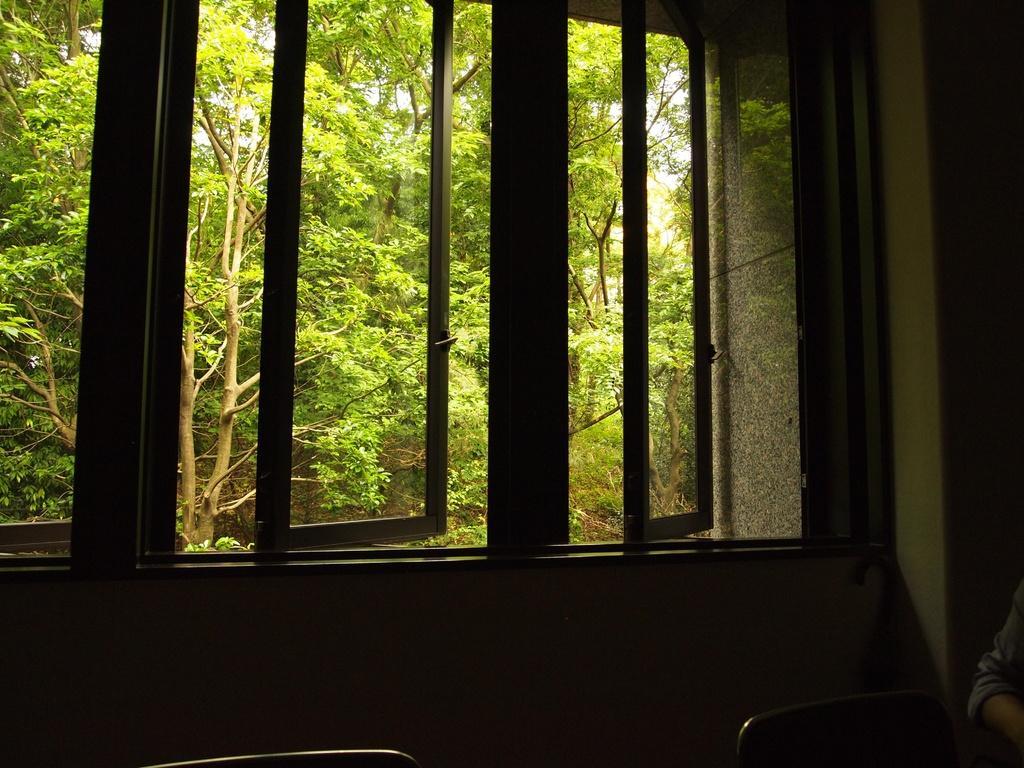Describe this image in one or two sentences. In this image we can see inside view of a building. On the right side of the image we can see a person, two chairs placed on the ground. In the background, we can see can see the windows and group of trees. 